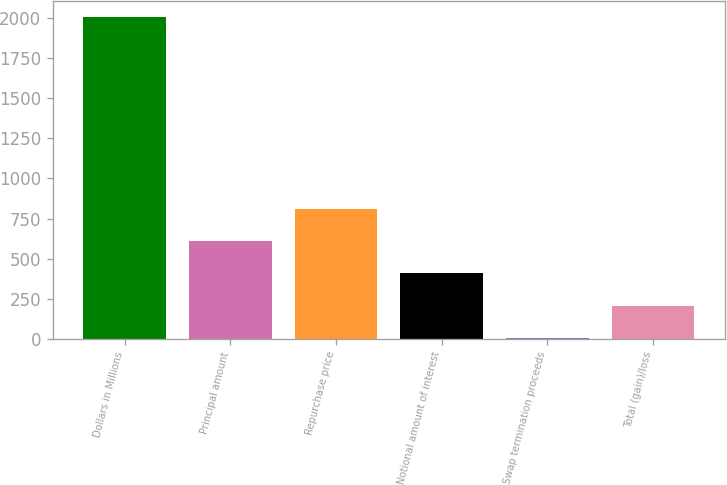Convert chart to OTSL. <chart><loc_0><loc_0><loc_500><loc_500><bar_chart><fcel>Dollars in Millions<fcel>Principal amount<fcel>Repurchase price<fcel>Notional amount of interest<fcel>Swap termination proceeds<fcel>Total (gain)/loss<nl><fcel>2009<fcel>607.6<fcel>807.8<fcel>407.4<fcel>7<fcel>207.2<nl></chart> 